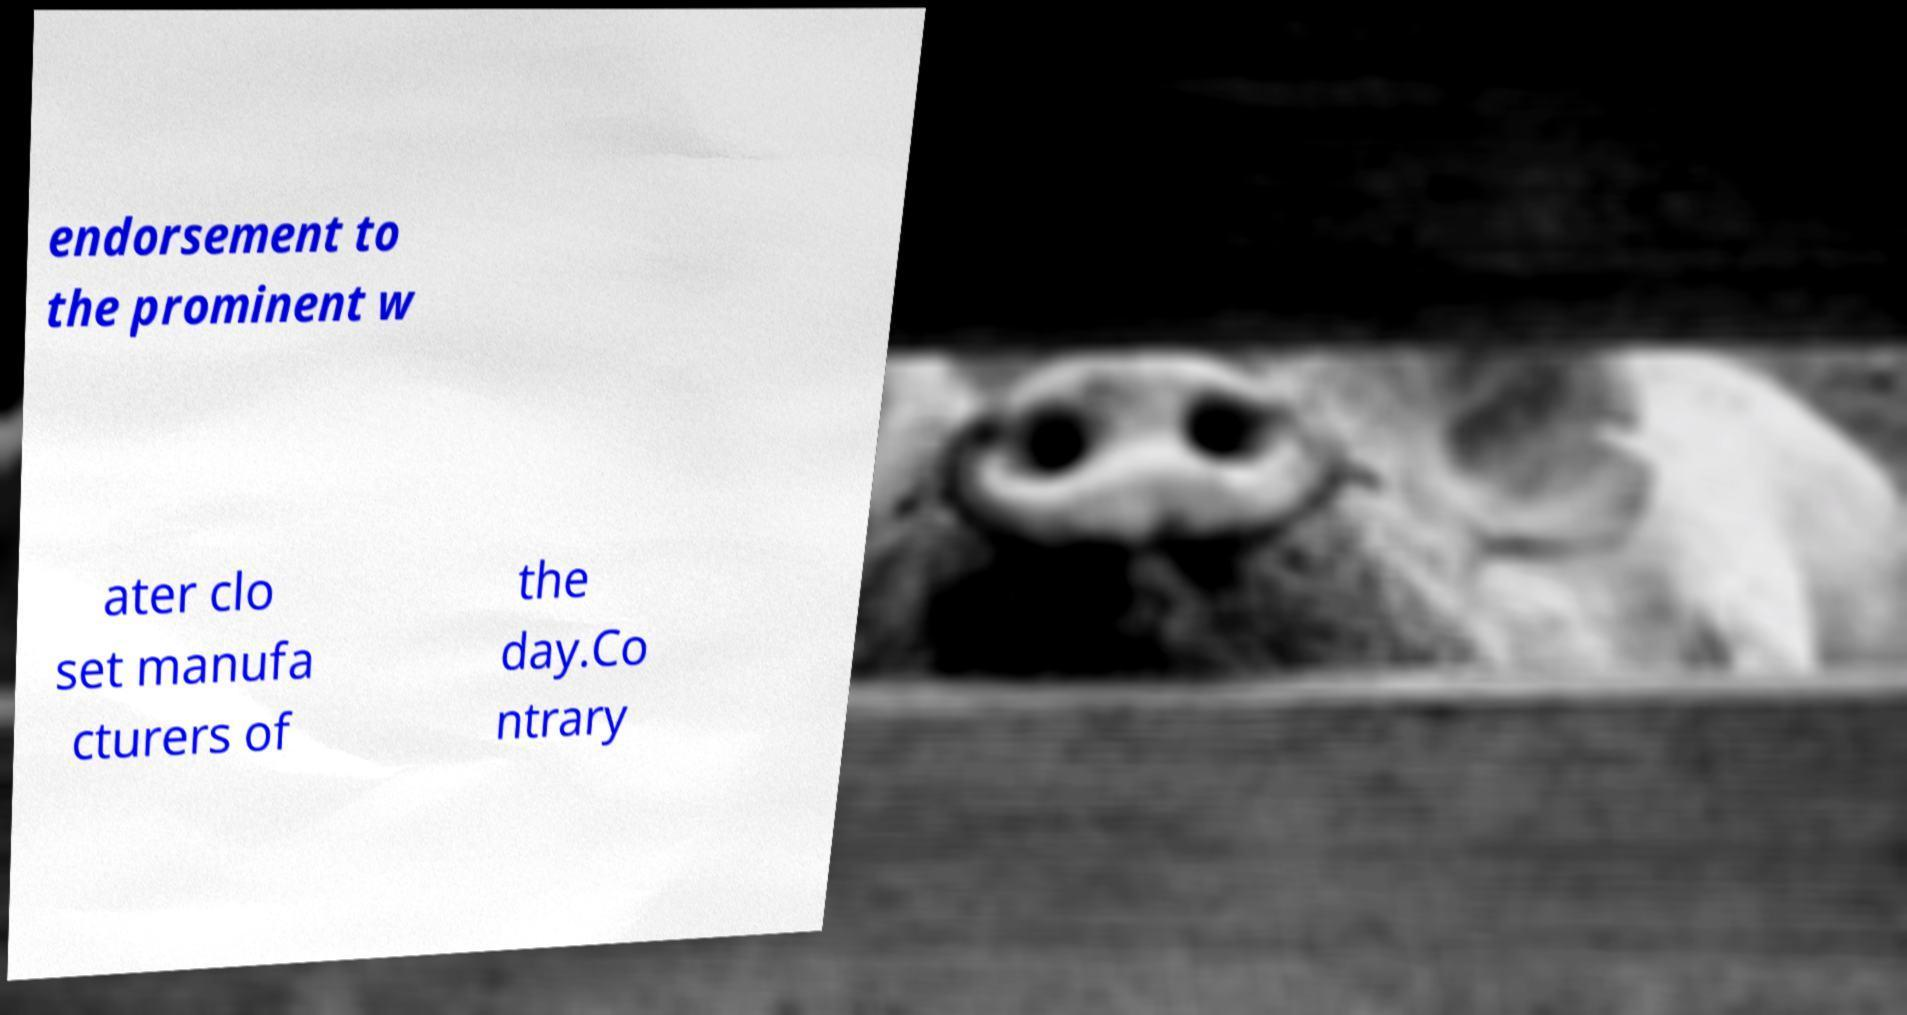Please read and relay the text visible in this image. What does it say? endorsement to the prominent w ater clo set manufa cturers of the day.Co ntrary 